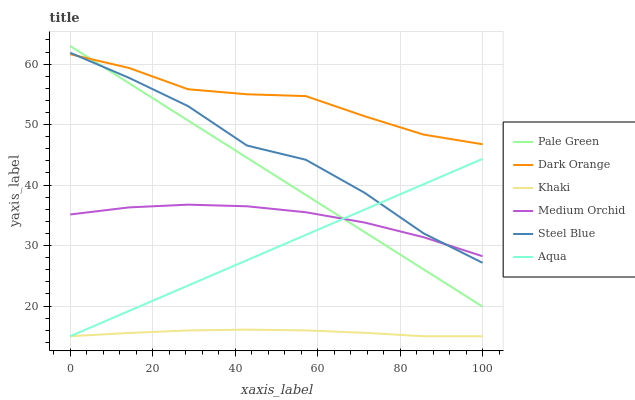Does Khaki have the minimum area under the curve?
Answer yes or no. Yes. Does Dark Orange have the maximum area under the curve?
Answer yes or no. Yes. Does Medium Orchid have the minimum area under the curve?
Answer yes or no. No. Does Medium Orchid have the maximum area under the curve?
Answer yes or no. No. Is Pale Green the smoothest?
Answer yes or no. Yes. Is Steel Blue the roughest?
Answer yes or no. Yes. Is Khaki the smoothest?
Answer yes or no. No. Is Khaki the roughest?
Answer yes or no. No. Does Khaki have the lowest value?
Answer yes or no. Yes. Does Medium Orchid have the lowest value?
Answer yes or no. No. Does Pale Green have the highest value?
Answer yes or no. Yes. Does Medium Orchid have the highest value?
Answer yes or no. No. Is Medium Orchid less than Dark Orange?
Answer yes or no. Yes. Is Pale Green greater than Khaki?
Answer yes or no. Yes. Does Medium Orchid intersect Pale Green?
Answer yes or no. Yes. Is Medium Orchid less than Pale Green?
Answer yes or no. No. Is Medium Orchid greater than Pale Green?
Answer yes or no. No. Does Medium Orchid intersect Dark Orange?
Answer yes or no. No. 